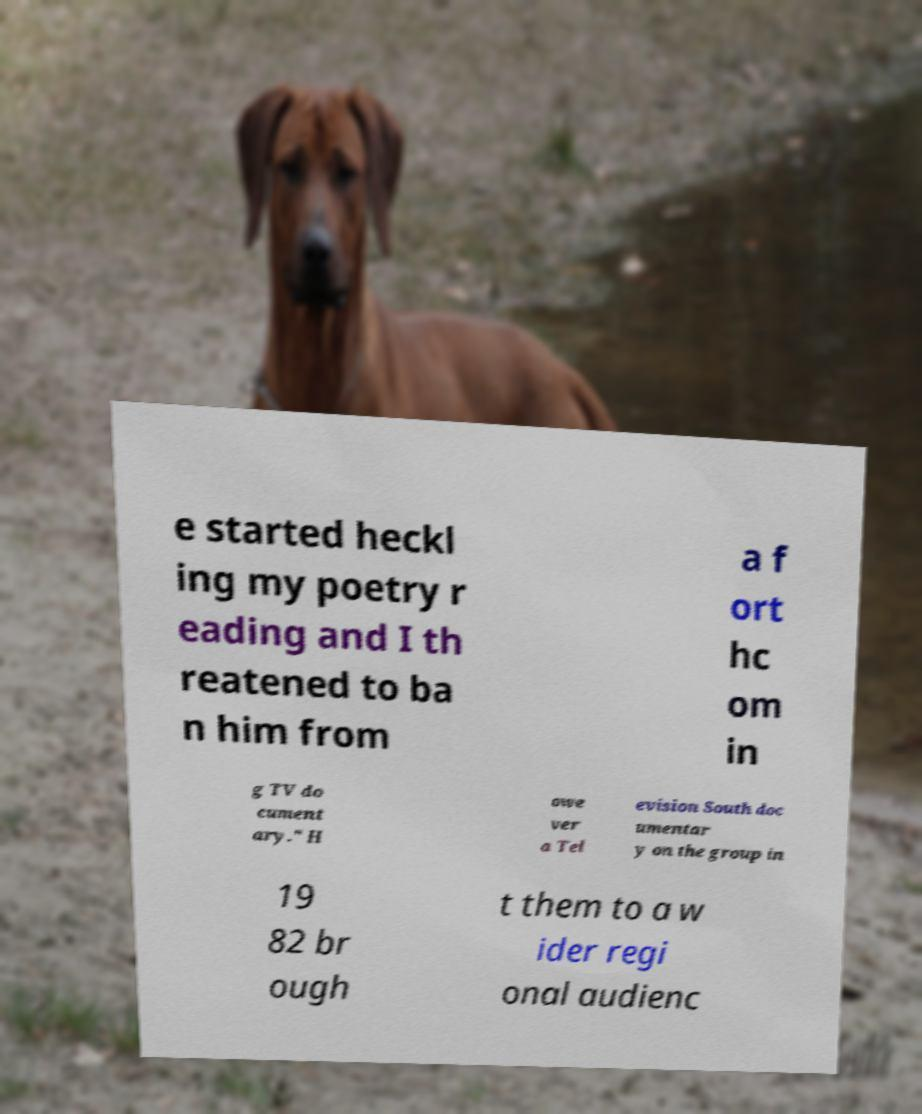Can you read and provide the text displayed in the image?This photo seems to have some interesting text. Can you extract and type it out for me? e started heckl ing my poetry r eading and I th reatened to ba n him from a f ort hc om in g TV do cument ary." H owe ver a Tel evision South doc umentar y on the group in 19 82 br ough t them to a w ider regi onal audienc 